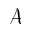Convert formula to latex. <formula><loc_0><loc_0><loc_500><loc_500>\mathcal { A }</formula> 